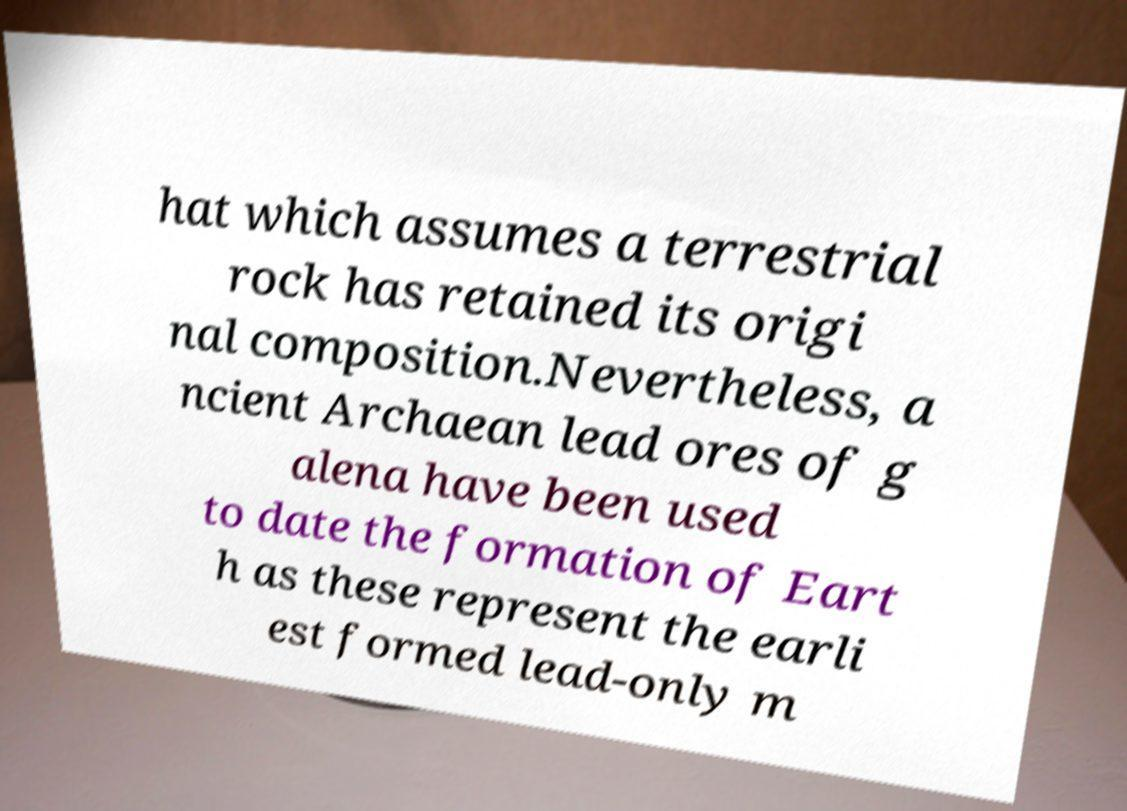What messages or text are displayed in this image? I need them in a readable, typed format. hat which assumes a terrestrial rock has retained its origi nal composition.Nevertheless, a ncient Archaean lead ores of g alena have been used to date the formation of Eart h as these represent the earli est formed lead-only m 